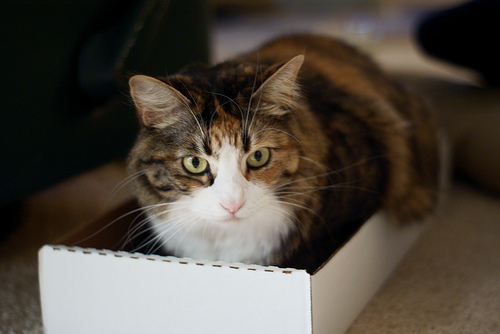<image>
Can you confirm if the cat is behind the box? No. The cat is not behind the box. From this viewpoint, the cat appears to be positioned elsewhere in the scene. 